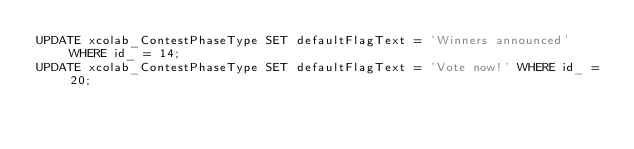<code> <loc_0><loc_0><loc_500><loc_500><_SQL_>UPDATE xcolab_ContestPhaseType SET defaultFlagText = 'Winners announced' WHERE id_ = 14;
UPDATE xcolab_ContestPhaseType SET defaultFlagText = 'Vote now!' WHERE id_ = 20;
</code> 